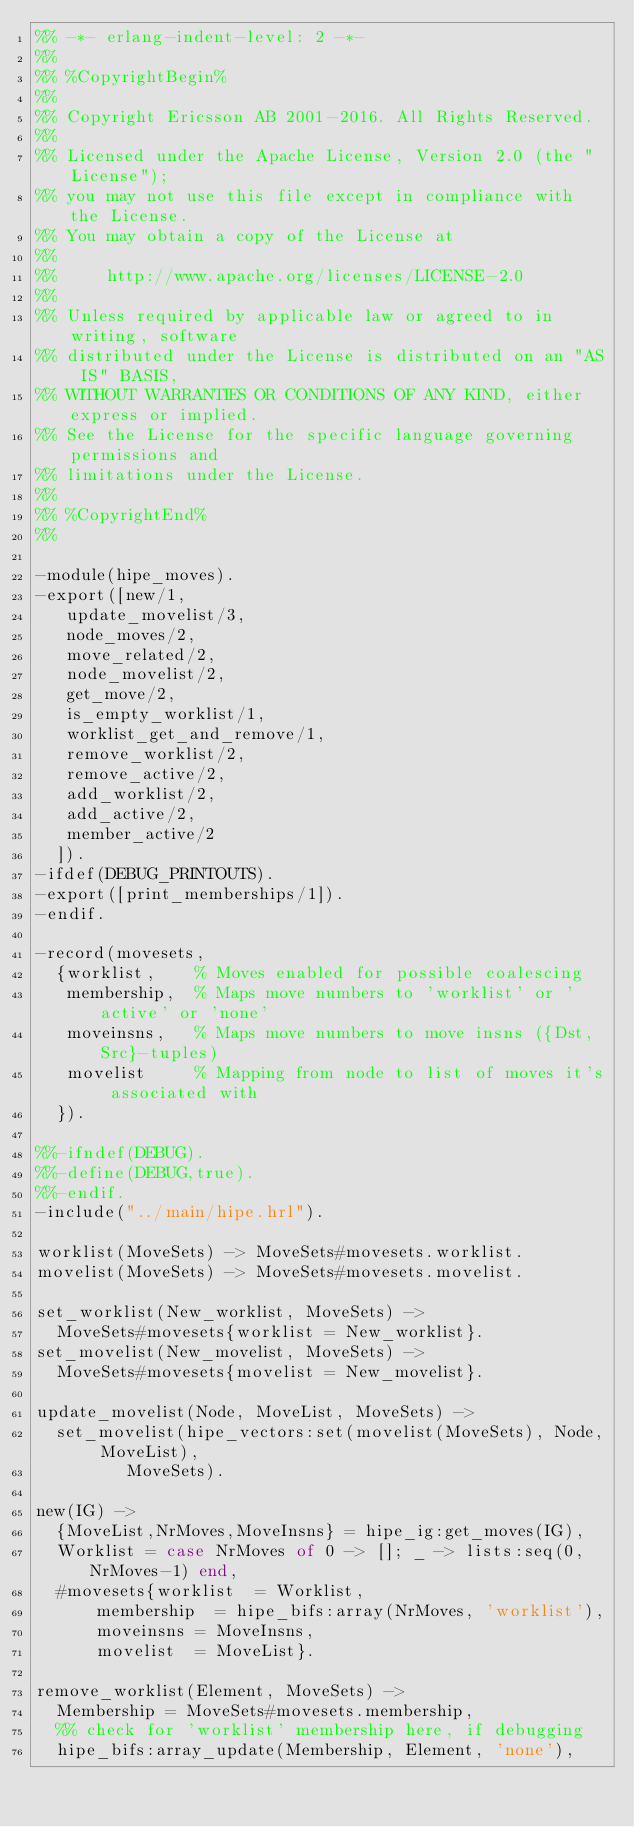Convert code to text. <code><loc_0><loc_0><loc_500><loc_500><_Erlang_>%% -*- erlang-indent-level: 2 -*-
%%
%% %CopyrightBegin%
%% 
%% Copyright Ericsson AB 2001-2016. All Rights Reserved.
%% 
%% Licensed under the Apache License, Version 2.0 (the "License");
%% you may not use this file except in compliance with the License.
%% You may obtain a copy of the License at
%%
%%     http://www.apache.org/licenses/LICENSE-2.0
%%
%% Unless required by applicable law or agreed to in writing, software
%% distributed under the License is distributed on an "AS IS" BASIS,
%% WITHOUT WARRANTIES OR CONDITIONS OF ANY KIND, either express or implied.
%% See the License for the specific language governing permissions and
%% limitations under the License.
%% 
%% %CopyrightEnd%
%%

-module(hipe_moves).
-export([new/1,
	 update_movelist/3,
	 node_moves/2,
	 move_related/2,
	 node_movelist/2,
	 get_move/2,
	 is_empty_worklist/1,
	 worklist_get_and_remove/1,
	 remove_worklist/2,
	 remove_active/2,
	 add_worklist/2,
	 add_active/2,
	 member_active/2
	]).
-ifdef(DEBUG_PRINTOUTS).
-export([print_memberships/1]).
-endif.

-record(movesets,
	{worklist,    % Moves enabled for possible coalescing
	 membership,  % Maps move numbers to 'worklist' or 'active' or 'none'
	 moveinsns,   % Maps move numbers to move insns ({Dst,Src}-tuples)
	 movelist     % Mapping from node to list of moves it's associated with
	}).

%%-ifndef(DEBUG).
%%-define(DEBUG,true).
%%-endif.
-include("../main/hipe.hrl").

worklist(MoveSets) -> MoveSets#movesets.worklist.
movelist(MoveSets) -> MoveSets#movesets.movelist.

set_worklist(New_worklist, MoveSets) ->
  MoveSets#movesets{worklist = New_worklist}.
set_movelist(New_movelist, MoveSets) ->
  MoveSets#movesets{movelist = New_movelist}.

update_movelist(Node, MoveList, MoveSets) ->
  set_movelist(hipe_vectors:set(movelist(MoveSets), Node, MoveList),
	       MoveSets).

new(IG) ->
  {MoveList,NrMoves,MoveInsns} = hipe_ig:get_moves(IG),
  Worklist = case NrMoves of 0 -> []; _ -> lists:seq(0, NrMoves-1) end,
  #movesets{worklist	= Worklist,
	    membership	= hipe_bifs:array(NrMoves, 'worklist'),
	    moveinsns	= MoveInsns,
	    movelist	= MoveList}.

remove_worklist(Element, MoveSets) ->
  Membership = MoveSets#movesets.membership,
  %% check for 'worklist' membership here, if debugging
  hipe_bifs:array_update(Membership, Element, 'none'),</code> 